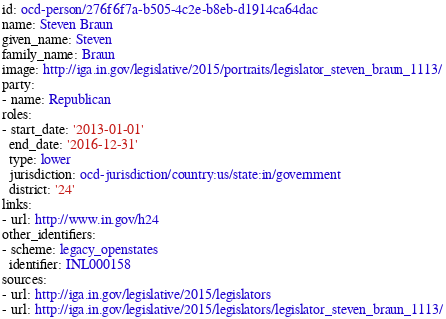<code> <loc_0><loc_0><loc_500><loc_500><_YAML_>id: ocd-person/276f6f7a-b505-4c2e-b8eb-d1914ca64dac
name: Steven Braun
given_name: Steven
family_name: Braun
image: http://iga.in.gov/legislative/2015/portraits/legislator_steven_braun_1113/
party:
- name: Republican
roles:
- start_date: '2013-01-01'
  end_date: '2016-12-31'
  type: lower
  jurisdiction: ocd-jurisdiction/country:us/state:in/government
  district: '24'
links:
- url: http://www.in.gov/h24
other_identifiers:
- scheme: legacy_openstates
  identifier: INL000158
sources:
- url: http://iga.in.gov/legislative/2015/legislators
- url: http://iga.in.gov/legislative/2015/legislators/legislator_steven_braun_1113/
</code> 